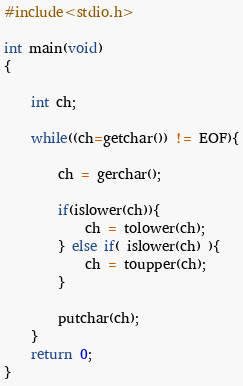<code> <loc_0><loc_0><loc_500><loc_500><_C_>#include<stdio.h>

int main(void)
{

	int ch;

	while((ch=getchar()) != EOF){
		
		ch = gerchar();		

		if(islower(ch)){
			ch = tolower(ch);
		} else if( islower(ch) ){
			ch = toupper(ch);
		}

		putchar(ch);
	}
	return 0;
}</code> 